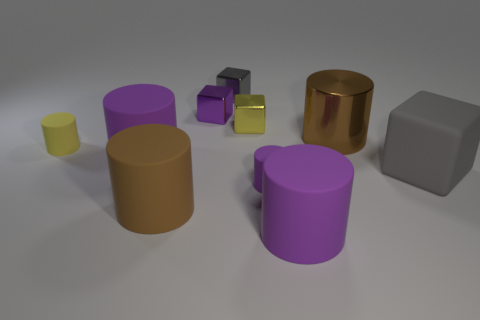Subtract all small blocks. How many blocks are left? 1 Subtract all brown cylinders. How many cylinders are left? 4 Subtract all cylinders. How many objects are left? 4 Subtract 2 cylinders. How many cylinders are left? 4 Subtract 0 green cubes. How many objects are left? 10 Subtract all green cubes. Subtract all blue balls. How many cubes are left? 4 Subtract all blue blocks. How many brown cylinders are left? 2 Subtract all small gray matte cylinders. Subtract all purple matte things. How many objects are left? 7 Add 6 purple blocks. How many purple blocks are left? 7 Add 6 large red rubber spheres. How many large red rubber spheres exist? 6 